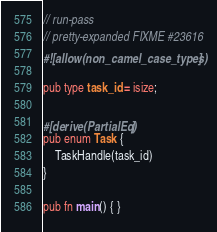<code> <loc_0><loc_0><loc_500><loc_500><_Rust_>// run-pass
// pretty-expanded FIXME #23616
#![allow(non_camel_case_types)]

pub type task_id = isize;

#[derive(PartialEq)]
pub enum Task {
    TaskHandle(task_id)
}

pub fn main() { }
</code> 